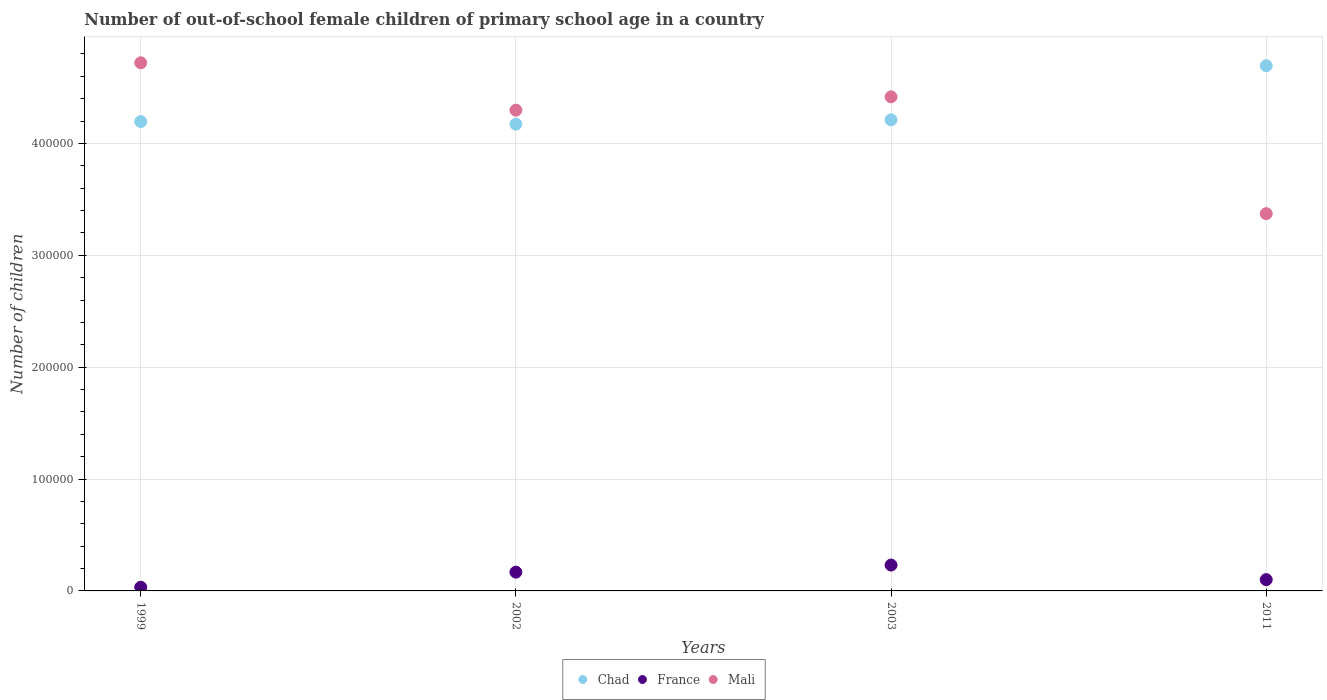What is the number of out-of-school female children in France in 2002?
Your response must be concise. 1.68e+04. Across all years, what is the maximum number of out-of-school female children in Chad?
Ensure brevity in your answer.  4.69e+05. Across all years, what is the minimum number of out-of-school female children in Chad?
Provide a succinct answer. 4.17e+05. In which year was the number of out-of-school female children in France minimum?
Ensure brevity in your answer.  1999. What is the total number of out-of-school female children in Mali in the graph?
Offer a very short reply. 1.68e+06. What is the difference between the number of out-of-school female children in France in 1999 and that in 2011?
Provide a short and direct response. -6831. What is the difference between the number of out-of-school female children in France in 2011 and the number of out-of-school female children in Chad in 1999?
Provide a short and direct response. -4.09e+05. What is the average number of out-of-school female children in France per year?
Your answer should be compact. 1.33e+04. In the year 1999, what is the difference between the number of out-of-school female children in Mali and number of out-of-school female children in Chad?
Give a very brief answer. 5.25e+04. In how many years, is the number of out-of-school female children in Mali greater than 440000?
Offer a very short reply. 2. What is the ratio of the number of out-of-school female children in Chad in 1999 to that in 2002?
Your answer should be very brief. 1.01. Is the number of out-of-school female children in France in 1999 less than that in 2011?
Make the answer very short. Yes. Is the difference between the number of out-of-school female children in Mali in 1999 and 2003 greater than the difference between the number of out-of-school female children in Chad in 1999 and 2003?
Make the answer very short. Yes. What is the difference between the highest and the second highest number of out-of-school female children in Chad?
Provide a succinct answer. 4.84e+04. What is the difference between the highest and the lowest number of out-of-school female children in France?
Ensure brevity in your answer.  1.99e+04. In how many years, is the number of out-of-school female children in Mali greater than the average number of out-of-school female children in Mali taken over all years?
Keep it short and to the point. 3. Is it the case that in every year, the sum of the number of out-of-school female children in France and number of out-of-school female children in Chad  is greater than the number of out-of-school female children in Mali?
Provide a short and direct response. No. Is the number of out-of-school female children in France strictly greater than the number of out-of-school female children in Mali over the years?
Make the answer very short. No. Is the number of out-of-school female children in Chad strictly less than the number of out-of-school female children in France over the years?
Your answer should be compact. No. How many years are there in the graph?
Ensure brevity in your answer.  4. Does the graph contain grids?
Ensure brevity in your answer.  Yes. How many legend labels are there?
Your answer should be very brief. 3. How are the legend labels stacked?
Make the answer very short. Horizontal. What is the title of the graph?
Offer a terse response. Number of out-of-school female children of primary school age in a country. Does "San Marino" appear as one of the legend labels in the graph?
Provide a short and direct response. No. What is the label or title of the X-axis?
Make the answer very short. Years. What is the label or title of the Y-axis?
Your response must be concise. Number of children. What is the Number of children of Chad in 1999?
Your answer should be compact. 4.20e+05. What is the Number of children of France in 1999?
Provide a succinct answer. 3258. What is the Number of children of Mali in 1999?
Offer a very short reply. 4.72e+05. What is the Number of children in Chad in 2002?
Make the answer very short. 4.17e+05. What is the Number of children in France in 2002?
Provide a succinct answer. 1.68e+04. What is the Number of children of Mali in 2002?
Make the answer very short. 4.30e+05. What is the Number of children in Chad in 2003?
Provide a short and direct response. 4.21e+05. What is the Number of children in France in 2003?
Provide a succinct answer. 2.31e+04. What is the Number of children of Mali in 2003?
Provide a short and direct response. 4.42e+05. What is the Number of children in Chad in 2011?
Offer a terse response. 4.69e+05. What is the Number of children of France in 2011?
Offer a terse response. 1.01e+04. What is the Number of children in Mali in 2011?
Give a very brief answer. 3.37e+05. Across all years, what is the maximum Number of children of Chad?
Offer a very short reply. 4.69e+05. Across all years, what is the maximum Number of children in France?
Your response must be concise. 2.31e+04. Across all years, what is the maximum Number of children of Mali?
Provide a succinct answer. 4.72e+05. Across all years, what is the minimum Number of children in Chad?
Offer a terse response. 4.17e+05. Across all years, what is the minimum Number of children in France?
Keep it short and to the point. 3258. Across all years, what is the minimum Number of children of Mali?
Give a very brief answer. 3.37e+05. What is the total Number of children of Chad in the graph?
Your response must be concise. 1.73e+06. What is the total Number of children of France in the graph?
Offer a terse response. 5.32e+04. What is the total Number of children of Mali in the graph?
Offer a terse response. 1.68e+06. What is the difference between the Number of children in Chad in 1999 and that in 2002?
Your response must be concise. 2365. What is the difference between the Number of children in France in 1999 and that in 2002?
Offer a very short reply. -1.35e+04. What is the difference between the Number of children of Mali in 1999 and that in 2002?
Offer a terse response. 4.23e+04. What is the difference between the Number of children of Chad in 1999 and that in 2003?
Provide a short and direct response. -1516. What is the difference between the Number of children in France in 1999 and that in 2003?
Keep it short and to the point. -1.99e+04. What is the difference between the Number of children of Mali in 1999 and that in 2003?
Your response must be concise. 3.04e+04. What is the difference between the Number of children of Chad in 1999 and that in 2011?
Your answer should be very brief. -4.99e+04. What is the difference between the Number of children in France in 1999 and that in 2011?
Give a very brief answer. -6831. What is the difference between the Number of children in Mali in 1999 and that in 2011?
Your response must be concise. 1.35e+05. What is the difference between the Number of children in Chad in 2002 and that in 2003?
Your answer should be compact. -3881. What is the difference between the Number of children of France in 2002 and that in 2003?
Offer a very short reply. -6317. What is the difference between the Number of children of Mali in 2002 and that in 2003?
Your answer should be very brief. -1.19e+04. What is the difference between the Number of children in Chad in 2002 and that in 2011?
Ensure brevity in your answer.  -5.22e+04. What is the difference between the Number of children in France in 2002 and that in 2011?
Keep it short and to the point. 6703. What is the difference between the Number of children in Mali in 2002 and that in 2011?
Keep it short and to the point. 9.25e+04. What is the difference between the Number of children in Chad in 2003 and that in 2011?
Make the answer very short. -4.84e+04. What is the difference between the Number of children in France in 2003 and that in 2011?
Give a very brief answer. 1.30e+04. What is the difference between the Number of children in Mali in 2003 and that in 2011?
Provide a succinct answer. 1.04e+05. What is the difference between the Number of children in Chad in 1999 and the Number of children in France in 2002?
Ensure brevity in your answer.  4.03e+05. What is the difference between the Number of children of Chad in 1999 and the Number of children of Mali in 2002?
Keep it short and to the point. -1.02e+04. What is the difference between the Number of children of France in 1999 and the Number of children of Mali in 2002?
Provide a short and direct response. -4.26e+05. What is the difference between the Number of children in Chad in 1999 and the Number of children in France in 2003?
Keep it short and to the point. 3.96e+05. What is the difference between the Number of children in Chad in 1999 and the Number of children in Mali in 2003?
Offer a very short reply. -2.21e+04. What is the difference between the Number of children in France in 1999 and the Number of children in Mali in 2003?
Make the answer very short. -4.38e+05. What is the difference between the Number of children in Chad in 1999 and the Number of children in France in 2011?
Provide a short and direct response. 4.09e+05. What is the difference between the Number of children in Chad in 1999 and the Number of children in Mali in 2011?
Offer a very short reply. 8.24e+04. What is the difference between the Number of children in France in 1999 and the Number of children in Mali in 2011?
Keep it short and to the point. -3.34e+05. What is the difference between the Number of children in Chad in 2002 and the Number of children in France in 2003?
Ensure brevity in your answer.  3.94e+05. What is the difference between the Number of children in Chad in 2002 and the Number of children in Mali in 2003?
Make the answer very short. -2.44e+04. What is the difference between the Number of children in France in 2002 and the Number of children in Mali in 2003?
Your answer should be very brief. -4.25e+05. What is the difference between the Number of children of Chad in 2002 and the Number of children of France in 2011?
Provide a succinct answer. 4.07e+05. What is the difference between the Number of children of Chad in 2002 and the Number of children of Mali in 2011?
Provide a short and direct response. 8.00e+04. What is the difference between the Number of children in France in 2002 and the Number of children in Mali in 2011?
Your answer should be compact. -3.20e+05. What is the difference between the Number of children in Chad in 2003 and the Number of children in France in 2011?
Your answer should be very brief. 4.11e+05. What is the difference between the Number of children in Chad in 2003 and the Number of children in Mali in 2011?
Make the answer very short. 8.39e+04. What is the difference between the Number of children of France in 2003 and the Number of children of Mali in 2011?
Offer a terse response. -3.14e+05. What is the average Number of children in Chad per year?
Keep it short and to the point. 4.32e+05. What is the average Number of children of France per year?
Provide a short and direct response. 1.33e+04. What is the average Number of children of Mali per year?
Your answer should be very brief. 4.20e+05. In the year 1999, what is the difference between the Number of children of Chad and Number of children of France?
Make the answer very short. 4.16e+05. In the year 1999, what is the difference between the Number of children of Chad and Number of children of Mali?
Keep it short and to the point. -5.25e+04. In the year 1999, what is the difference between the Number of children in France and Number of children in Mali?
Your answer should be very brief. -4.69e+05. In the year 2002, what is the difference between the Number of children in Chad and Number of children in France?
Your answer should be very brief. 4.00e+05. In the year 2002, what is the difference between the Number of children of Chad and Number of children of Mali?
Your response must be concise. -1.25e+04. In the year 2002, what is the difference between the Number of children of France and Number of children of Mali?
Your response must be concise. -4.13e+05. In the year 2003, what is the difference between the Number of children of Chad and Number of children of France?
Your answer should be very brief. 3.98e+05. In the year 2003, what is the difference between the Number of children in Chad and Number of children in Mali?
Offer a terse response. -2.05e+04. In the year 2003, what is the difference between the Number of children of France and Number of children of Mali?
Offer a very short reply. -4.19e+05. In the year 2011, what is the difference between the Number of children in Chad and Number of children in France?
Your response must be concise. 4.59e+05. In the year 2011, what is the difference between the Number of children in Chad and Number of children in Mali?
Ensure brevity in your answer.  1.32e+05. In the year 2011, what is the difference between the Number of children of France and Number of children of Mali?
Offer a very short reply. -3.27e+05. What is the ratio of the Number of children of Chad in 1999 to that in 2002?
Give a very brief answer. 1.01. What is the ratio of the Number of children of France in 1999 to that in 2002?
Provide a short and direct response. 0.19. What is the ratio of the Number of children of Mali in 1999 to that in 2002?
Provide a succinct answer. 1.1. What is the ratio of the Number of children of Chad in 1999 to that in 2003?
Provide a succinct answer. 1. What is the ratio of the Number of children in France in 1999 to that in 2003?
Make the answer very short. 0.14. What is the ratio of the Number of children in Mali in 1999 to that in 2003?
Your response must be concise. 1.07. What is the ratio of the Number of children of Chad in 1999 to that in 2011?
Keep it short and to the point. 0.89. What is the ratio of the Number of children of France in 1999 to that in 2011?
Your answer should be compact. 0.32. What is the ratio of the Number of children in Mali in 1999 to that in 2011?
Keep it short and to the point. 1.4. What is the ratio of the Number of children of France in 2002 to that in 2003?
Your response must be concise. 0.73. What is the ratio of the Number of children in Mali in 2002 to that in 2003?
Offer a very short reply. 0.97. What is the ratio of the Number of children of Chad in 2002 to that in 2011?
Your response must be concise. 0.89. What is the ratio of the Number of children of France in 2002 to that in 2011?
Provide a succinct answer. 1.66. What is the ratio of the Number of children of Mali in 2002 to that in 2011?
Offer a terse response. 1.27. What is the ratio of the Number of children in Chad in 2003 to that in 2011?
Your response must be concise. 0.9. What is the ratio of the Number of children of France in 2003 to that in 2011?
Your response must be concise. 2.29. What is the ratio of the Number of children of Mali in 2003 to that in 2011?
Keep it short and to the point. 1.31. What is the difference between the highest and the second highest Number of children of Chad?
Make the answer very short. 4.84e+04. What is the difference between the highest and the second highest Number of children in France?
Provide a succinct answer. 6317. What is the difference between the highest and the second highest Number of children in Mali?
Ensure brevity in your answer.  3.04e+04. What is the difference between the highest and the lowest Number of children in Chad?
Your response must be concise. 5.22e+04. What is the difference between the highest and the lowest Number of children in France?
Provide a succinct answer. 1.99e+04. What is the difference between the highest and the lowest Number of children of Mali?
Offer a very short reply. 1.35e+05. 